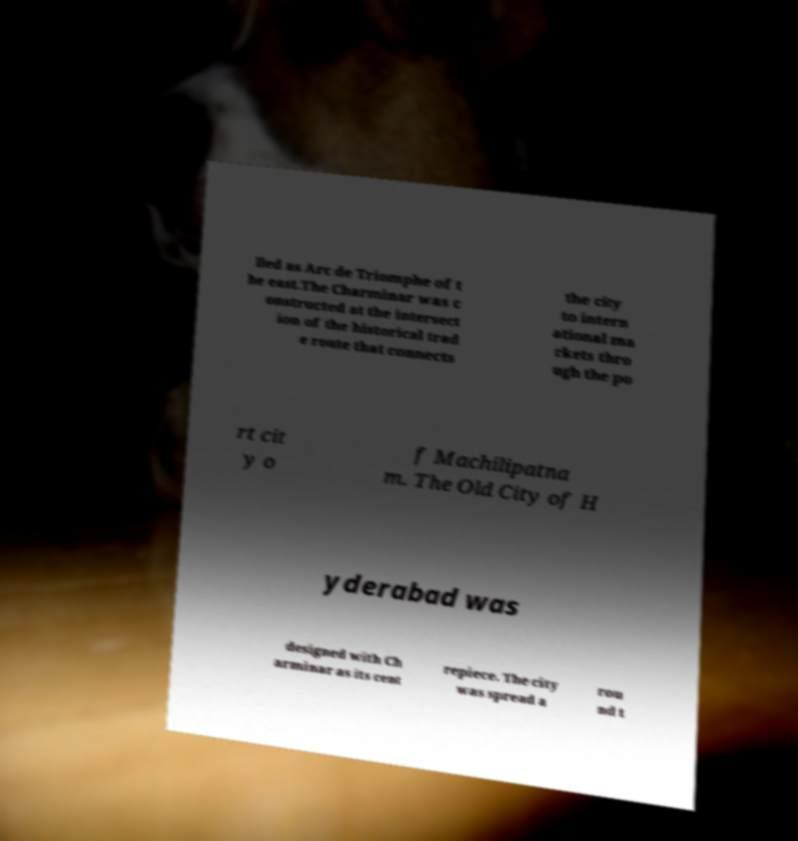Please read and relay the text visible in this image. What does it say? lled as Arc de Triomphe of t he east.The Charminar was c onstructed at the intersect ion of the historical trad e route that connects the city to intern ational ma rkets thro ugh the po rt cit y o f Machilipatna m. The Old City of H yderabad was designed with Ch arminar as its cent repiece. The city was spread a rou nd t 